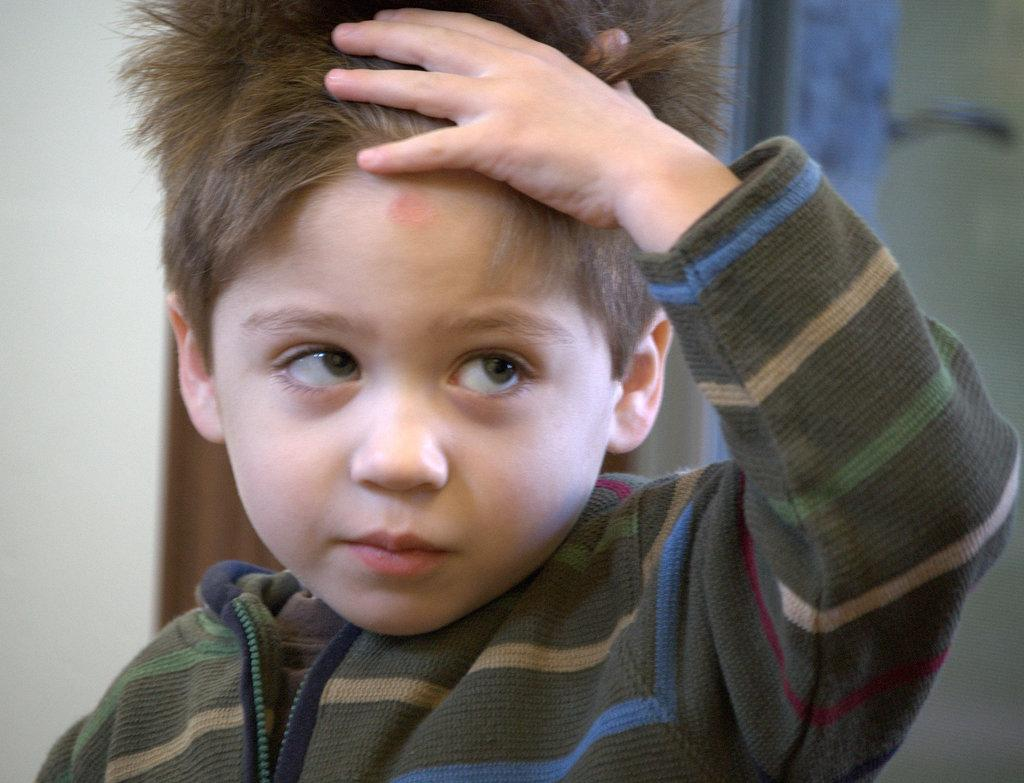Who is the main subject in the image? There is a boy in the image. What is the boy wearing? The boy is wearing a t-shirt. In which direction is the boy looking? The boy is looking to the right side. What can be seen in the background of the image? There is a wall in the background of the image. What type of yarn is the boy holding in the image? There is no yarn present in the image; the boy is not holding any yarn. 